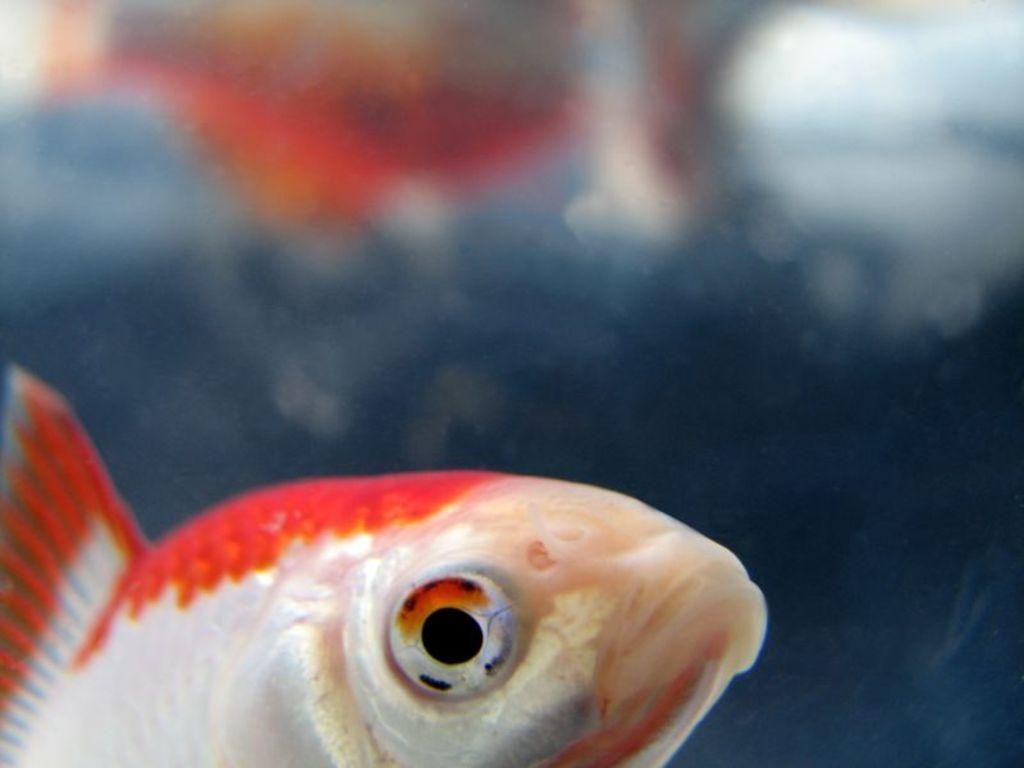What is located at the bottom of the image? There is a fish at the bottom of the image. Can you describe the background of the image? The background of the image is blurred. What type of environment is depicted in the image? There is water visible in the image, suggesting an aquatic environment. What is the manager's role in the image? There is no manager present in the image, as it features a fish in an aquatic environment. 